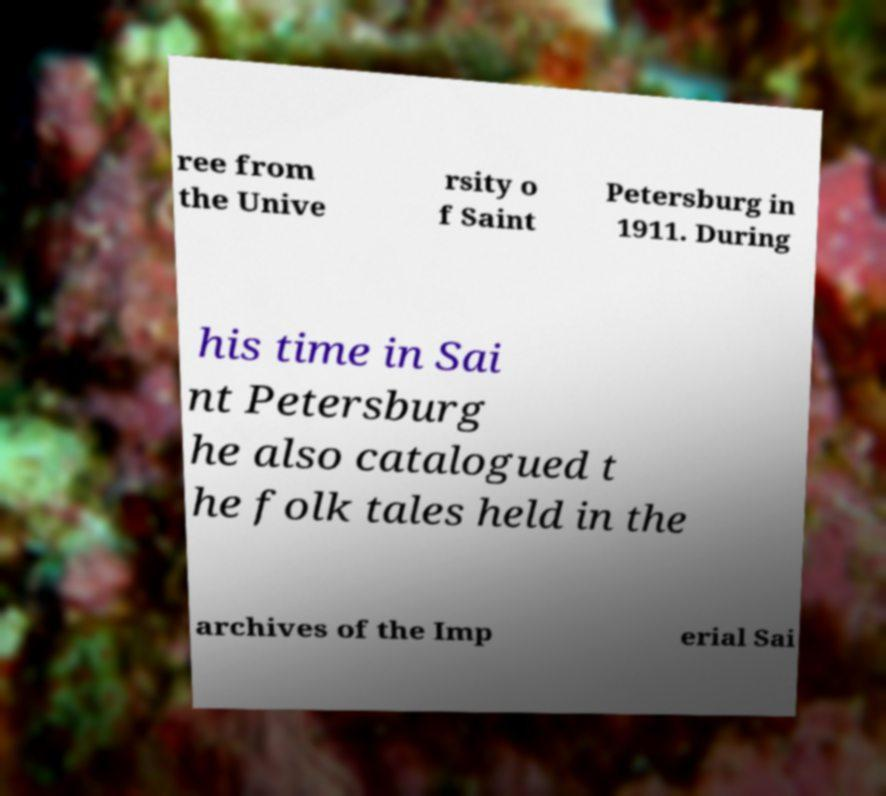Could you extract and type out the text from this image? ree from the Unive rsity o f Saint Petersburg in 1911. During his time in Sai nt Petersburg he also catalogued t he folk tales held in the archives of the Imp erial Sai 